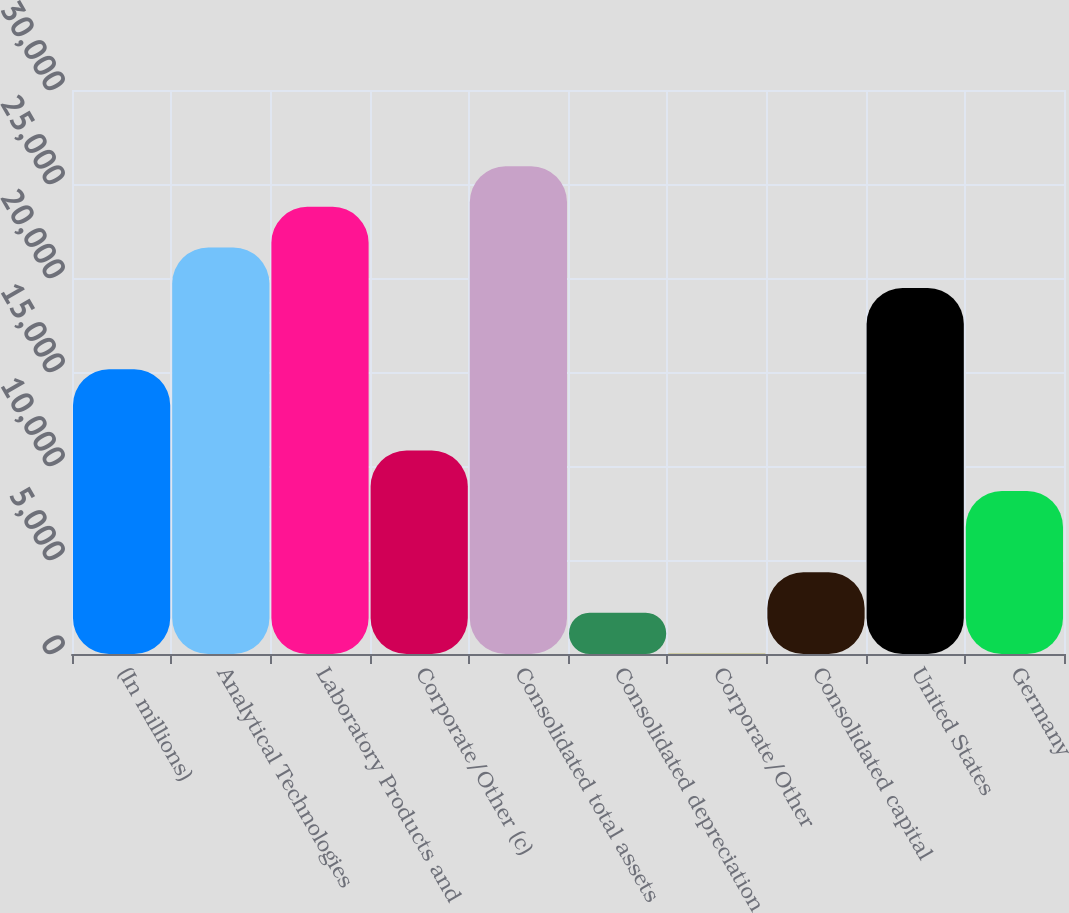<chart> <loc_0><loc_0><loc_500><loc_500><bar_chart><fcel>(In millions)<fcel>Analytical Technologies<fcel>Laboratory Products and<fcel>Corporate/Other (c)<fcel>Consolidated total assets<fcel>Consolidated depreciation<fcel>Corporate/Other<fcel>Consolidated capital<fcel>United States<fcel>Germany<nl><fcel>15147.1<fcel>21625<fcel>23784.3<fcel>10828.5<fcel>25943.6<fcel>2191.21<fcel>31.9<fcel>4350.52<fcel>19465.7<fcel>8669.14<nl></chart> 